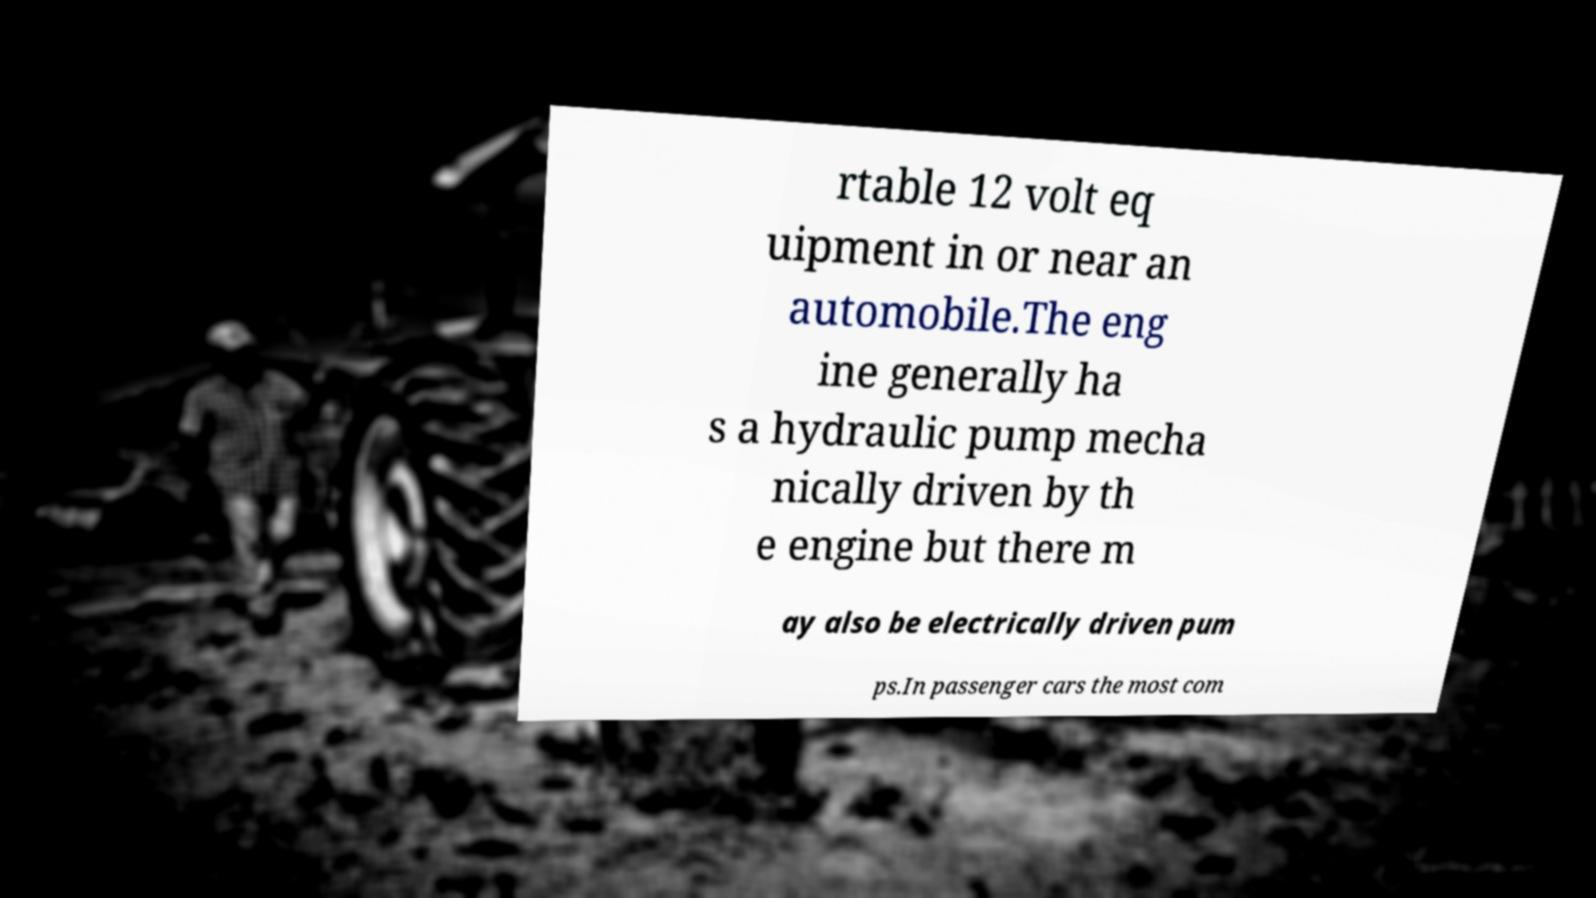Can you accurately transcribe the text from the provided image for me? rtable 12 volt eq uipment in or near an automobile.The eng ine generally ha s a hydraulic pump mecha nically driven by th e engine but there m ay also be electrically driven pum ps.In passenger cars the most com 